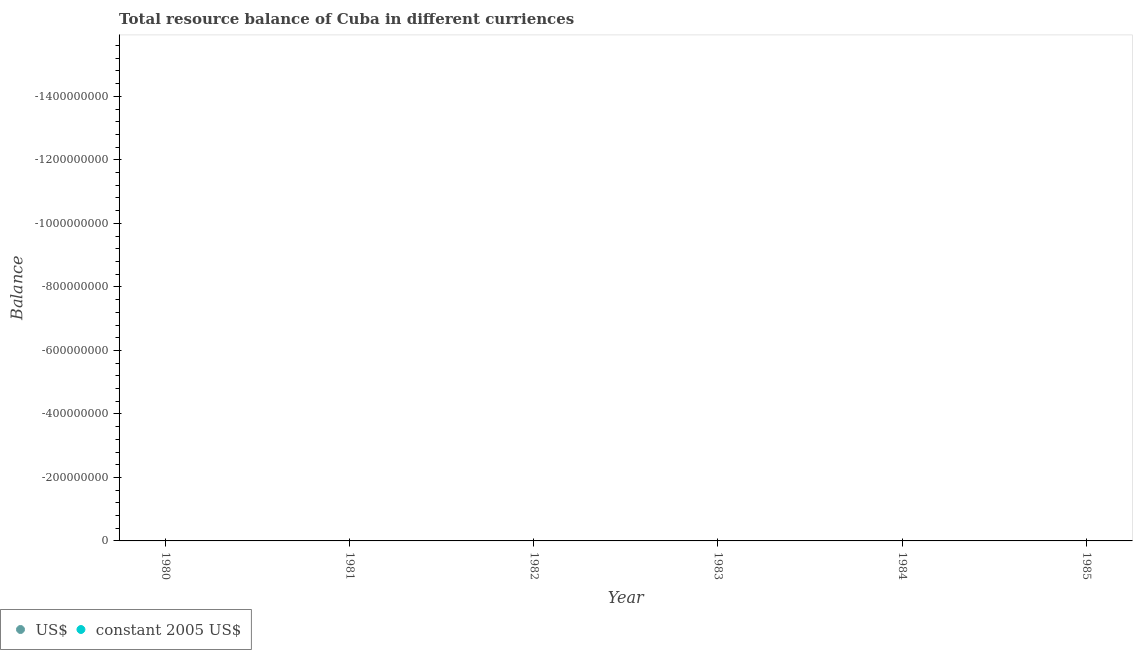How many different coloured dotlines are there?
Provide a short and direct response. 0. Is the number of dotlines equal to the number of legend labels?
Make the answer very short. No. Across all years, what is the minimum resource balance in us$?
Offer a terse response. 0. What is the total resource balance in us$ in the graph?
Your answer should be compact. 0. What is the difference between the resource balance in constant us$ in 1982 and the resource balance in us$ in 1983?
Keep it short and to the point. 0. What is the average resource balance in us$ per year?
Ensure brevity in your answer.  0. In how many years, is the resource balance in constant us$ greater than -1480000000 units?
Offer a terse response. 0. In how many years, is the resource balance in constant us$ greater than the average resource balance in constant us$ taken over all years?
Your response must be concise. 0. Does the resource balance in us$ monotonically increase over the years?
Offer a very short reply. No. Is the resource balance in us$ strictly less than the resource balance in constant us$ over the years?
Your response must be concise. Yes. How many years are there in the graph?
Provide a short and direct response. 6. What is the difference between two consecutive major ticks on the Y-axis?
Ensure brevity in your answer.  2.00e+08. Does the graph contain grids?
Your answer should be very brief. No. How many legend labels are there?
Your response must be concise. 2. What is the title of the graph?
Provide a short and direct response. Total resource balance of Cuba in different curriences. Does "Diesel" appear as one of the legend labels in the graph?
Offer a very short reply. No. What is the label or title of the X-axis?
Provide a short and direct response. Year. What is the label or title of the Y-axis?
Offer a terse response. Balance. What is the Balance in constant 2005 US$ in 1980?
Ensure brevity in your answer.  0. What is the Balance of US$ in 1982?
Offer a very short reply. 0. What is the Balance of constant 2005 US$ in 1983?
Give a very brief answer. 0. What is the Balance of US$ in 1985?
Keep it short and to the point. 0. What is the Balance of constant 2005 US$ in 1985?
Offer a terse response. 0. What is the total Balance of US$ in the graph?
Your answer should be compact. 0. What is the average Balance of constant 2005 US$ per year?
Provide a succinct answer. 0. 